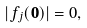Convert formula to latex. <formula><loc_0><loc_0><loc_500><loc_500>| f _ { j } ( \mathbf 0 ) | = 0 ,</formula> 